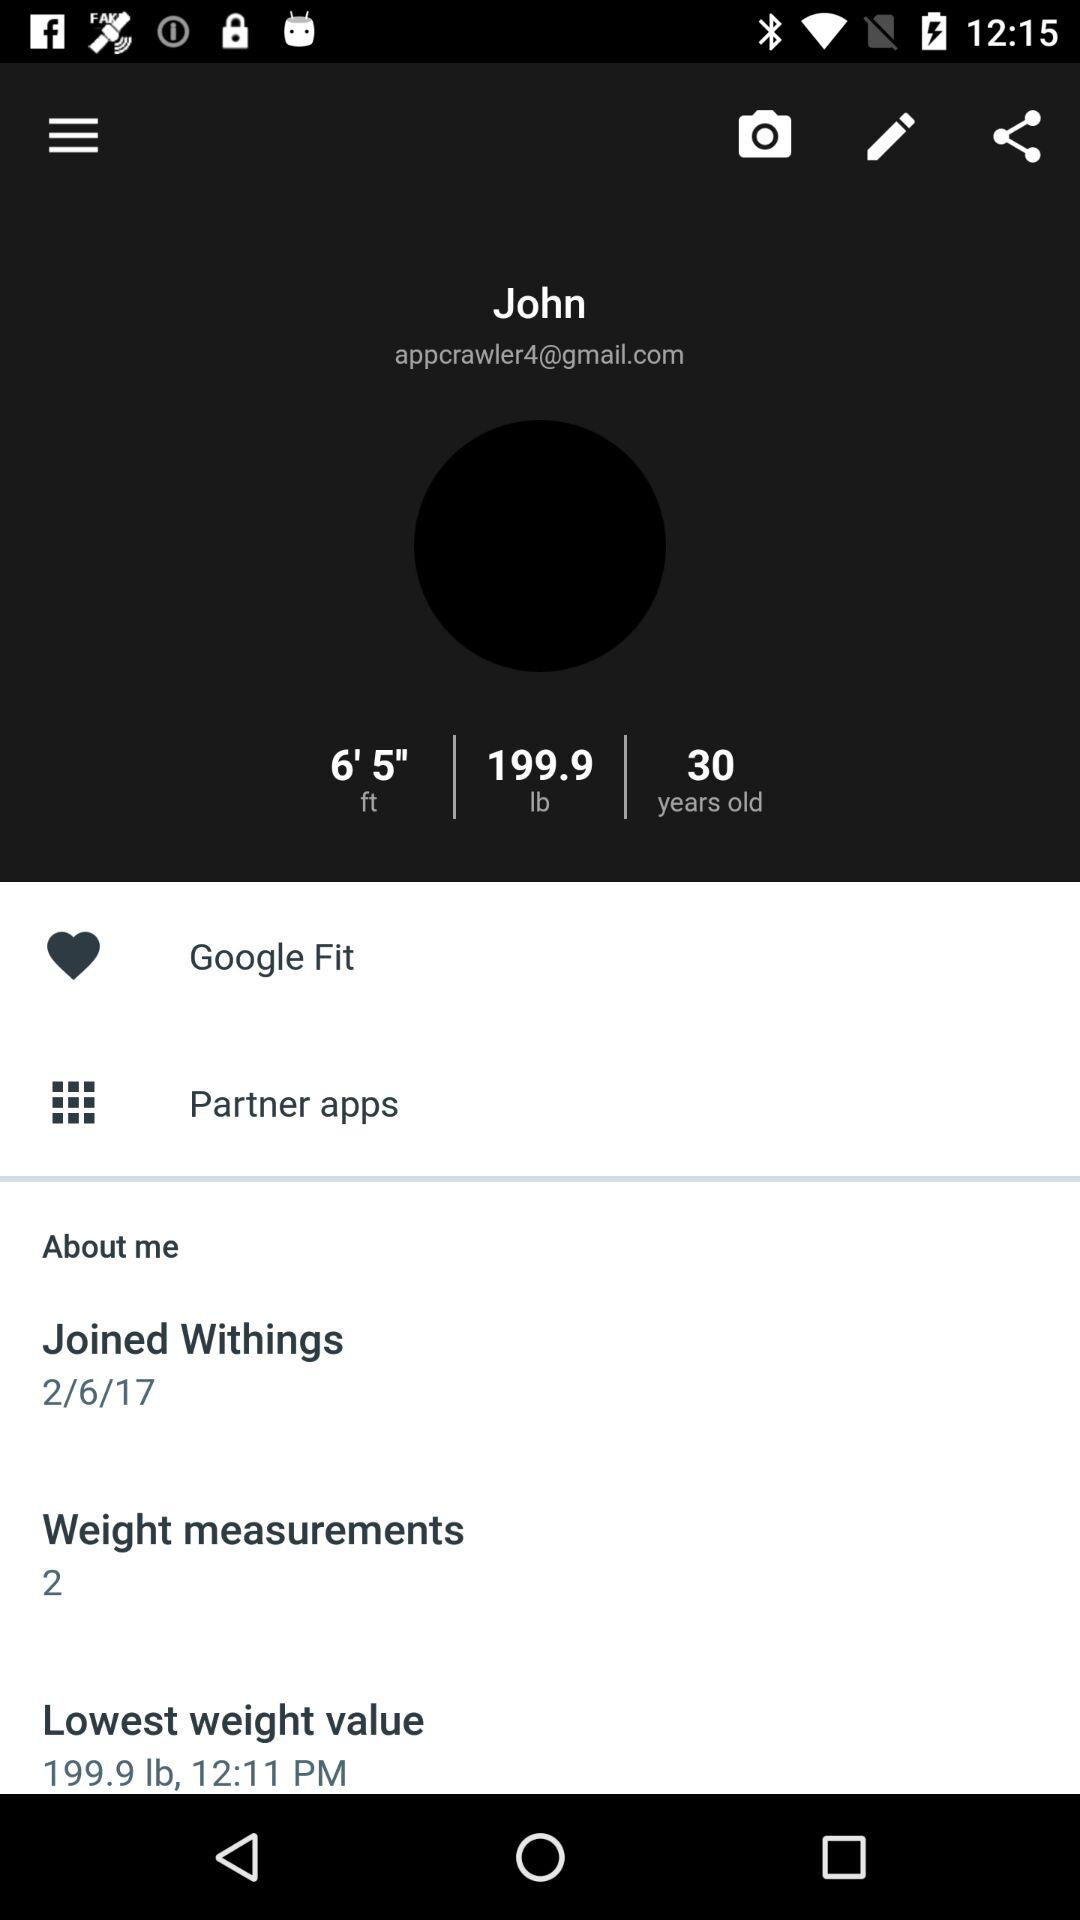What is the joining date? The joining date is 2/6/17. 